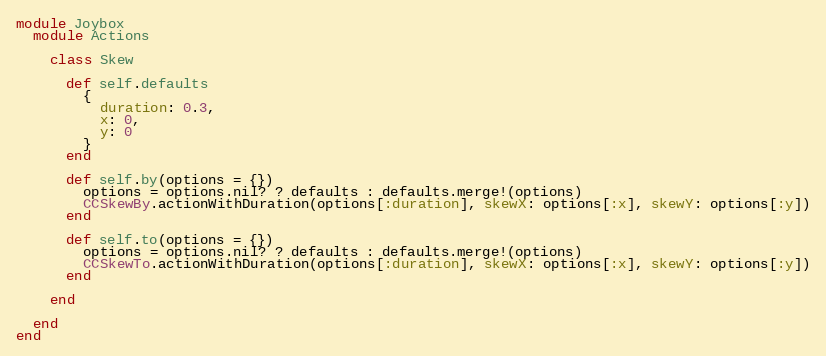Convert code to text. <code><loc_0><loc_0><loc_500><loc_500><_Ruby_>module Joybox
  module Actions

    class Skew

      def self.defaults
        {
          duration: 0.3,
          x: 0,
          y: 0
        }
      end

      def self.by(options = {})
        options = options.nil? ? defaults : defaults.merge!(options)
        CCSkewBy.actionWithDuration(options[:duration], skewX: options[:x], skewY: options[:y])
      end

      def self.to(options = {})
        options = options.nil? ? defaults : defaults.merge!(options)
        CCSkewTo.actionWithDuration(options[:duration], skewX: options[:x], skewY: options[:y])
      end

    end

  end
end</code> 